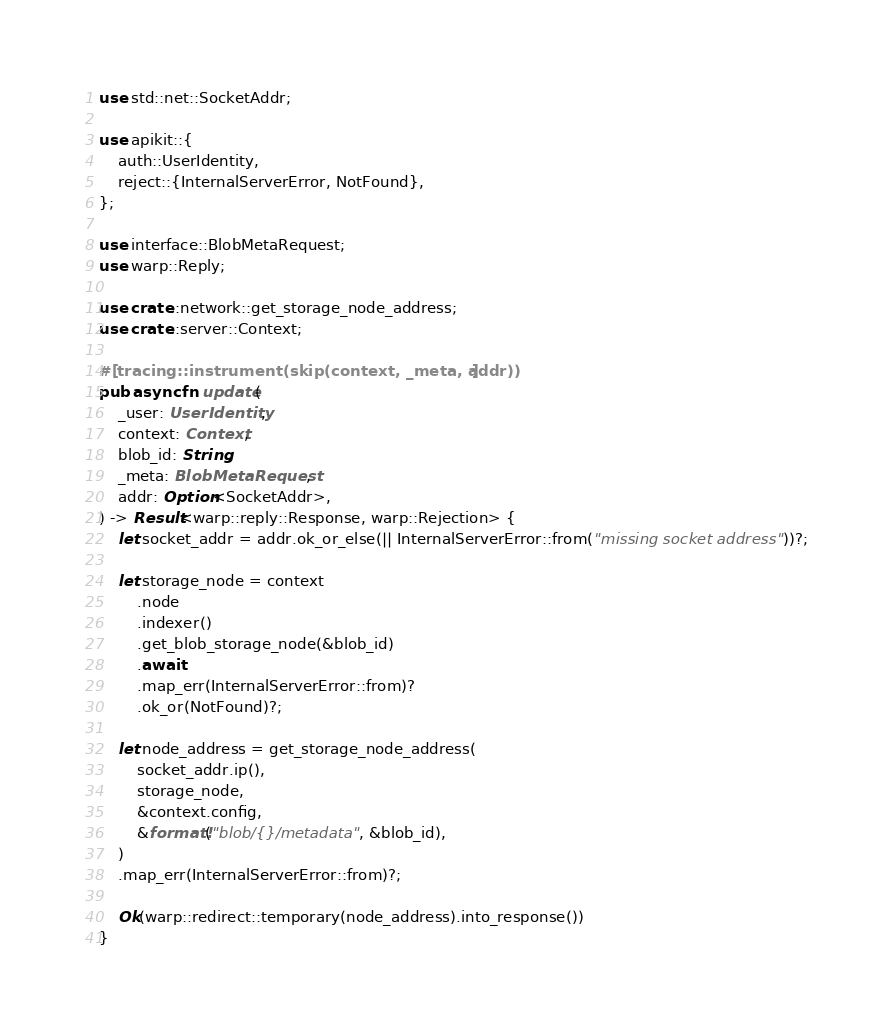<code> <loc_0><loc_0><loc_500><loc_500><_Rust_>use std::net::SocketAddr;

use apikit::{
    auth::UserIdentity,
    reject::{InternalServerError, NotFound},
};

use interface::BlobMetaRequest;
use warp::Reply;

use crate::network::get_storage_node_address;
use crate::server::Context;

#[tracing::instrument(skip(context, _meta, addr))]
pub async fn update(
    _user: UserIdentity,
    context: Context,
    blob_id: String,
    _meta: BlobMetaRequest,
    addr: Option<SocketAddr>,
) -> Result<warp::reply::Response, warp::Rejection> {
    let socket_addr = addr.ok_or_else(|| InternalServerError::from("missing socket address"))?;

    let storage_node = context
        .node
        .indexer()
        .get_blob_storage_node(&blob_id)
        .await
        .map_err(InternalServerError::from)?
        .ok_or(NotFound)?;

    let node_address = get_storage_node_address(
        socket_addr.ip(),
        storage_node,
        &context.config,
        &format!("blob/{}/metadata", &blob_id),
    )
    .map_err(InternalServerError::from)?;

    Ok(warp::redirect::temporary(node_address).into_response())
}
</code> 